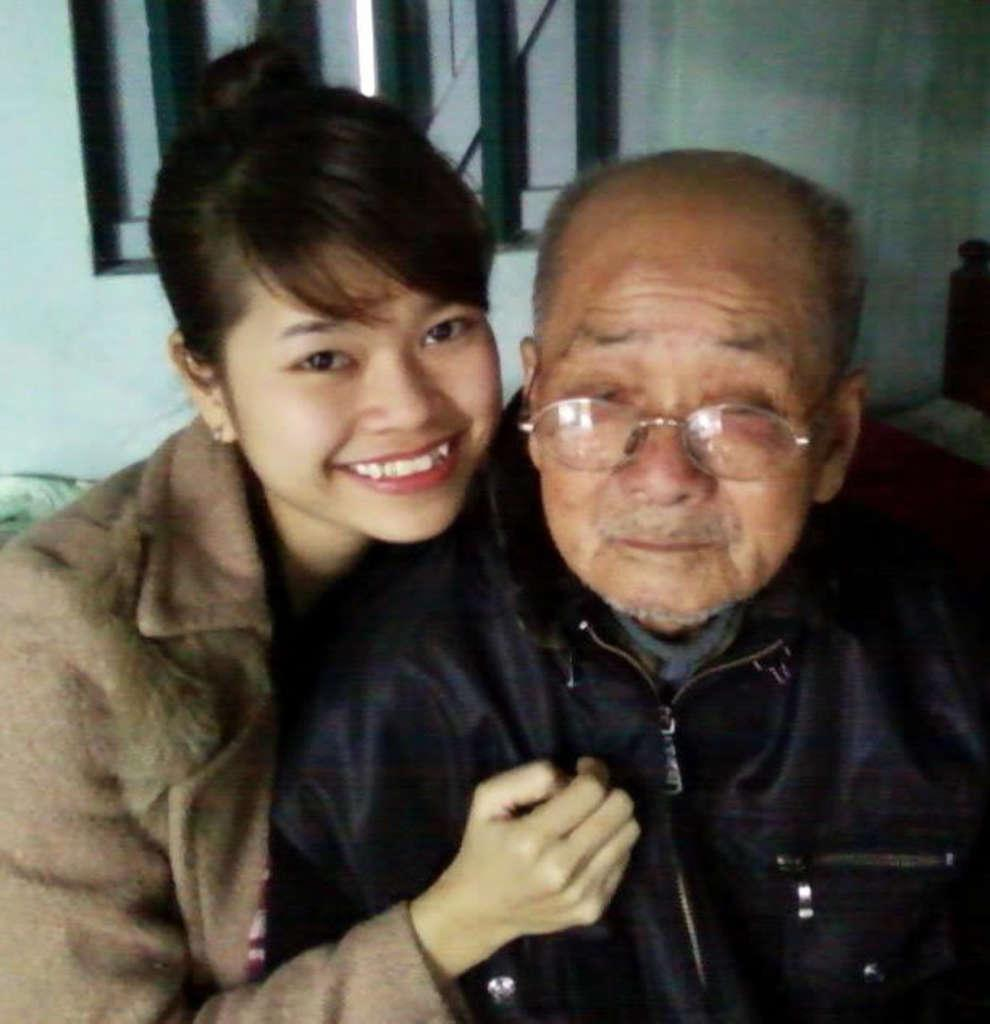Who is present in the image? There is a lady in the image. What is the facial expression of the person in the image? There is a person with a smile in the image. How are the lady and the person feeling in the image? The lady and the person are smiling, which suggests they are happy or enjoying themselves. What can be seen on the wall in the image? There is a wall with a window in the image. What architectural feature is present in the image? There are stairs in the image. What type of fang can be seen in the image? There is no fang present in the image. What is the air quality like in the image? The provided facts do not give any information about the air quality in the image. 